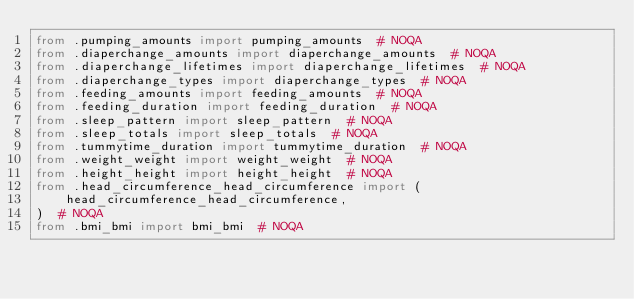<code> <loc_0><loc_0><loc_500><loc_500><_Python_>from .pumping_amounts import pumping_amounts  # NOQA
from .diaperchange_amounts import diaperchange_amounts  # NOQA
from .diaperchange_lifetimes import diaperchange_lifetimes  # NOQA
from .diaperchange_types import diaperchange_types  # NOQA
from .feeding_amounts import feeding_amounts  # NOQA
from .feeding_duration import feeding_duration  # NOQA
from .sleep_pattern import sleep_pattern  # NOQA
from .sleep_totals import sleep_totals  # NOQA
from .tummytime_duration import tummytime_duration  # NOQA
from .weight_weight import weight_weight  # NOQA
from .height_height import height_height  # NOQA
from .head_circumference_head_circumference import (
    head_circumference_head_circumference,
)  # NOQA
from .bmi_bmi import bmi_bmi  # NOQA
</code> 